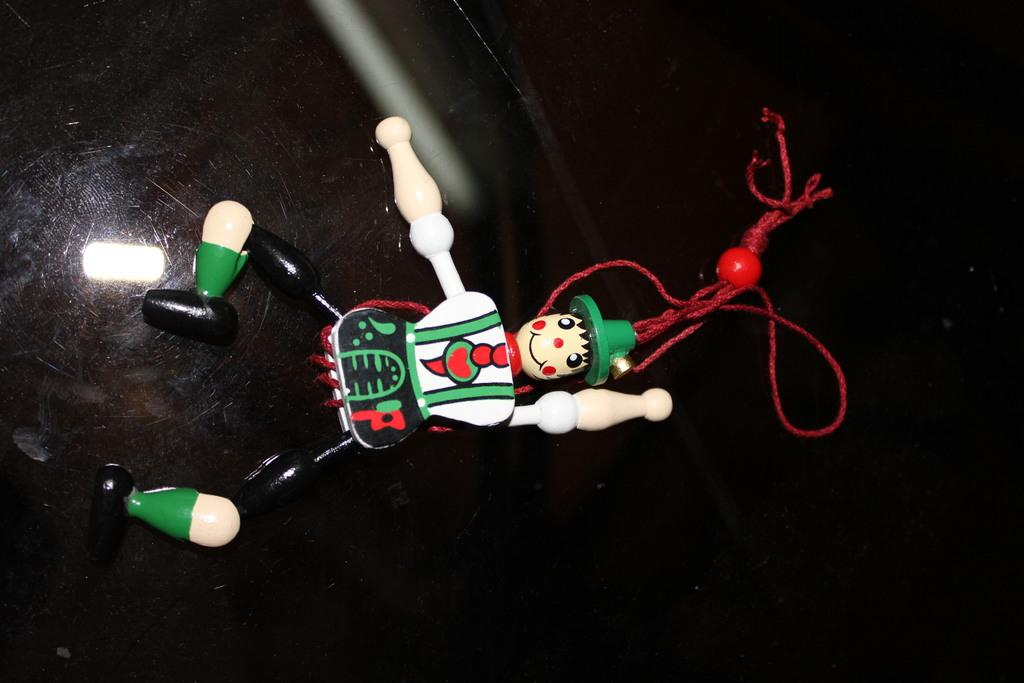What is the main subject of the image? There is a doll in the image. What else can be seen in the image besides the doll? There is some thread in the image. What is the color of the background in the image? The background of the image is black. What type of office furniture can be seen in the image? There is no office furniture present in the image; it features a doll and some thread against a black background. What group of people might be interacting with the doll in the image? There is no group of people present in the image; it only shows a doll and some thread against a black background. 